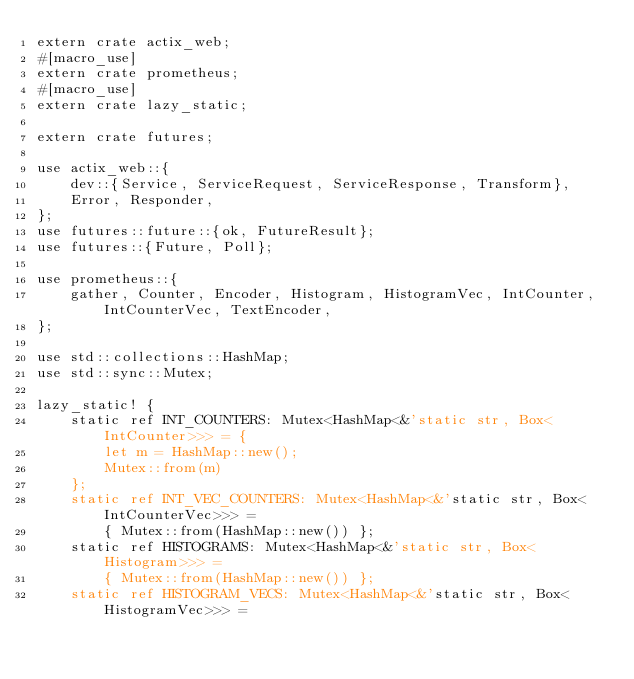Convert code to text. <code><loc_0><loc_0><loc_500><loc_500><_Rust_>extern crate actix_web;
#[macro_use]
extern crate prometheus;
#[macro_use]
extern crate lazy_static;

extern crate futures;

use actix_web::{
    dev::{Service, ServiceRequest, ServiceResponse, Transform},
    Error, Responder,
};
use futures::future::{ok, FutureResult};
use futures::{Future, Poll};

use prometheus::{
    gather, Counter, Encoder, Histogram, HistogramVec, IntCounter, IntCounterVec, TextEncoder,
};

use std::collections::HashMap;
use std::sync::Mutex;

lazy_static! {
    static ref INT_COUNTERS: Mutex<HashMap<&'static str, Box<IntCounter>>> = {
        let m = HashMap::new();
        Mutex::from(m)
    };
    static ref INT_VEC_COUNTERS: Mutex<HashMap<&'static str, Box<IntCounterVec>>> =
        { Mutex::from(HashMap::new()) };
    static ref HISTOGRAMS: Mutex<HashMap<&'static str, Box<Histogram>>> =
        { Mutex::from(HashMap::new()) };
    static ref HISTOGRAM_VECS: Mutex<HashMap<&'static str, Box<HistogramVec>>> =</code> 